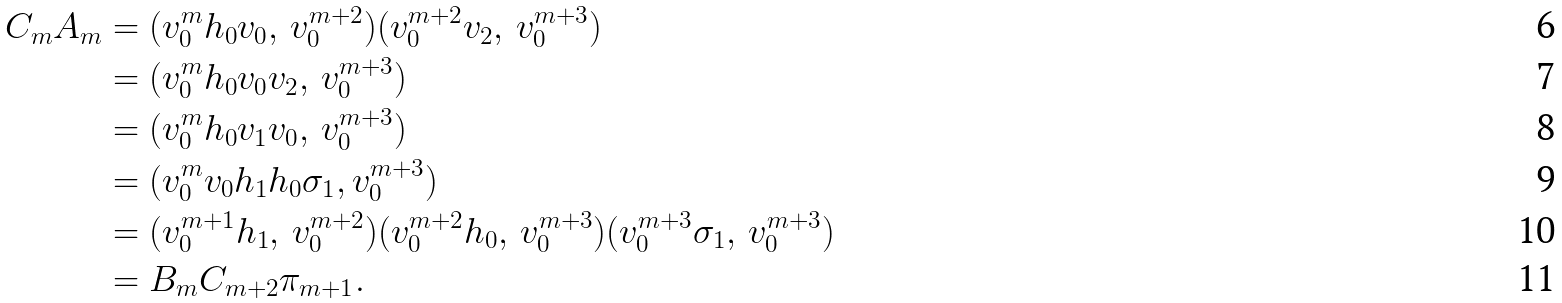Convert formula to latex. <formula><loc_0><loc_0><loc_500><loc_500>C _ { m } A _ { m } & = ( v _ { 0 } ^ { m } h _ { 0 } v _ { 0 } , \, v _ { 0 } ^ { m + 2 } ) ( v _ { 0 } ^ { m + 2 } v _ { 2 } , \, v _ { 0 } ^ { m + 3 } ) \\ & = ( v _ { 0 } ^ { m } h _ { 0 } v _ { 0 } v _ { 2 } , \, v _ { 0 } ^ { m + 3 } ) \\ & = ( v _ { 0 } ^ { m } h _ { 0 } v _ { 1 } v _ { 0 } , \, v _ { 0 } ^ { m + 3 } ) \\ & = ( v _ { 0 } ^ { m } v _ { 0 } h _ { 1 } h _ { 0 } \sigma _ { 1 } , v _ { 0 } ^ { m + 3 } ) \\ & = ( v _ { 0 } ^ { m + 1 } h _ { 1 } , \, v _ { 0 } ^ { m + 2 } ) ( v _ { 0 } ^ { m + 2 } h _ { 0 } , \, v _ { 0 } ^ { m + 3 } ) ( v _ { 0 } ^ { m + 3 } \sigma _ { 1 } , \, v _ { 0 } ^ { m + 3 } ) \\ & = B _ { m } C _ { m + 2 } \pi _ { m + 1 } .</formula> 